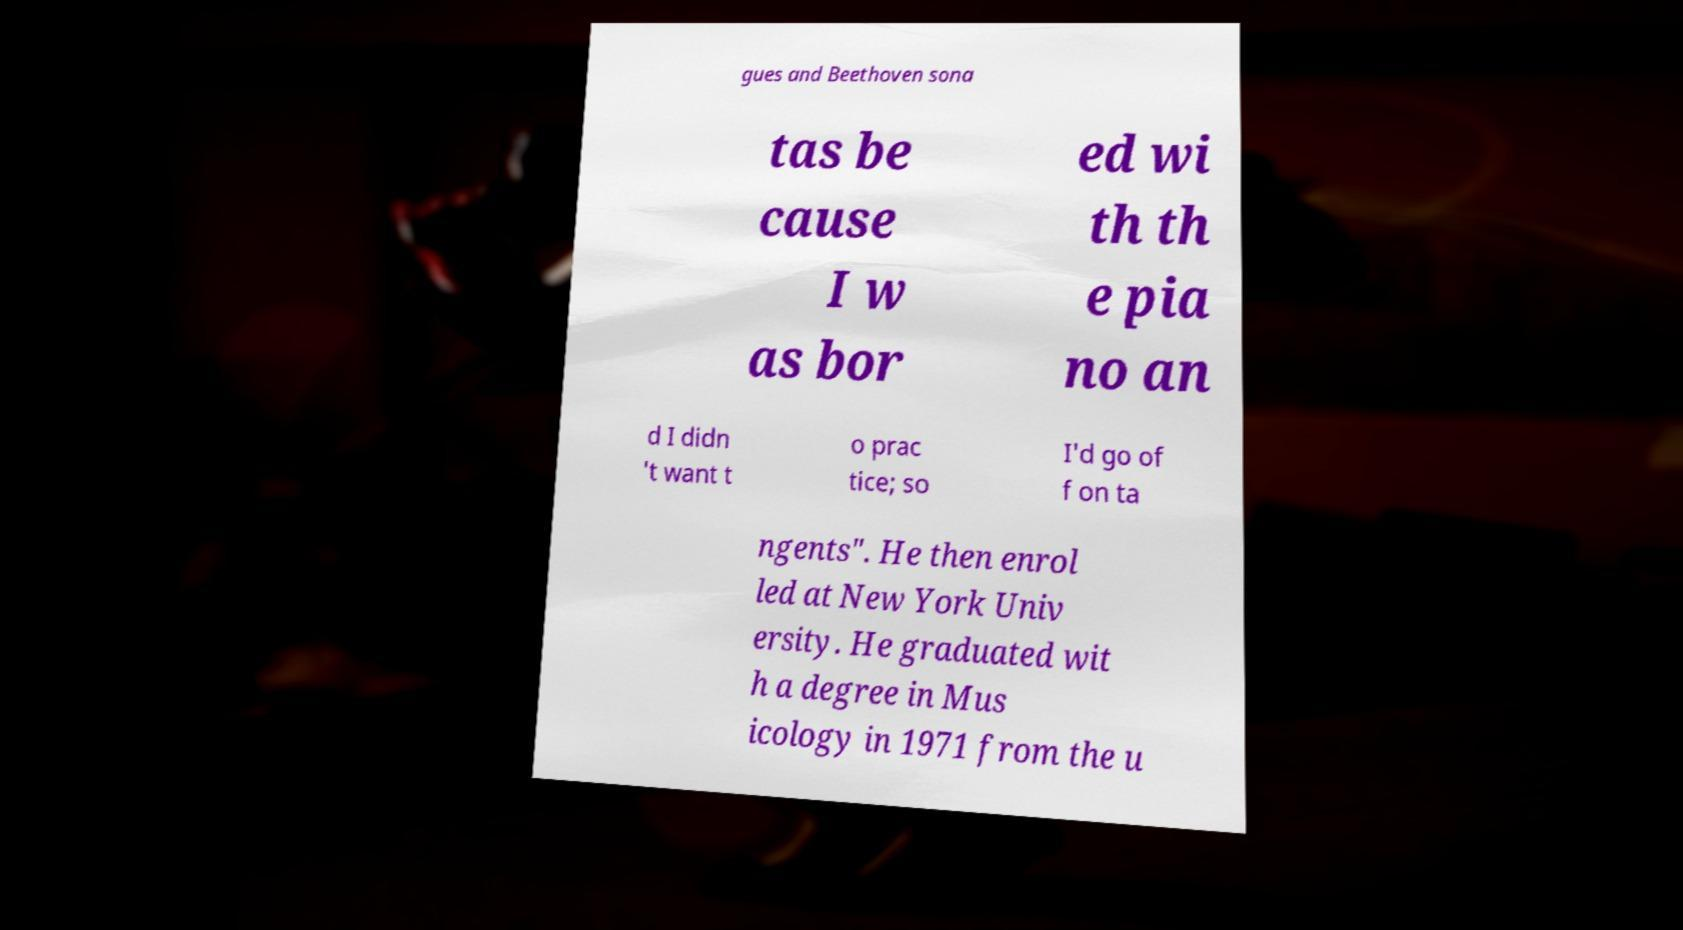Can you read and provide the text displayed in the image?This photo seems to have some interesting text. Can you extract and type it out for me? gues and Beethoven sona tas be cause I w as bor ed wi th th e pia no an d I didn 't want t o prac tice; so I'd go of f on ta ngents". He then enrol led at New York Univ ersity. He graduated wit h a degree in Mus icology in 1971 from the u 